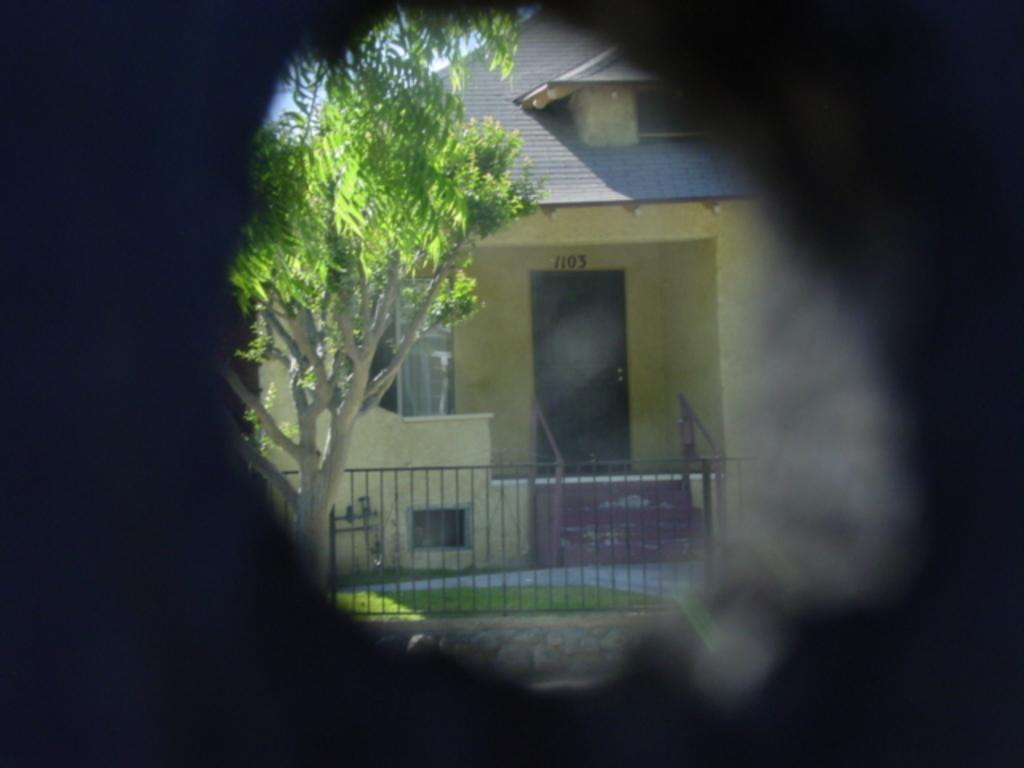What is the main structure in the middle of the image? There is a building in the middle of the image. What type of vegetation is on the left side of the image? There is a tree at the left side of the image. What type of architectural feature is at the bottom of the image? There is a fencing gate at the bottom of the image. What type of cloth is draped over the tree in the image? There is no cloth draped over the tree in the image; only the tree and the building are present. 